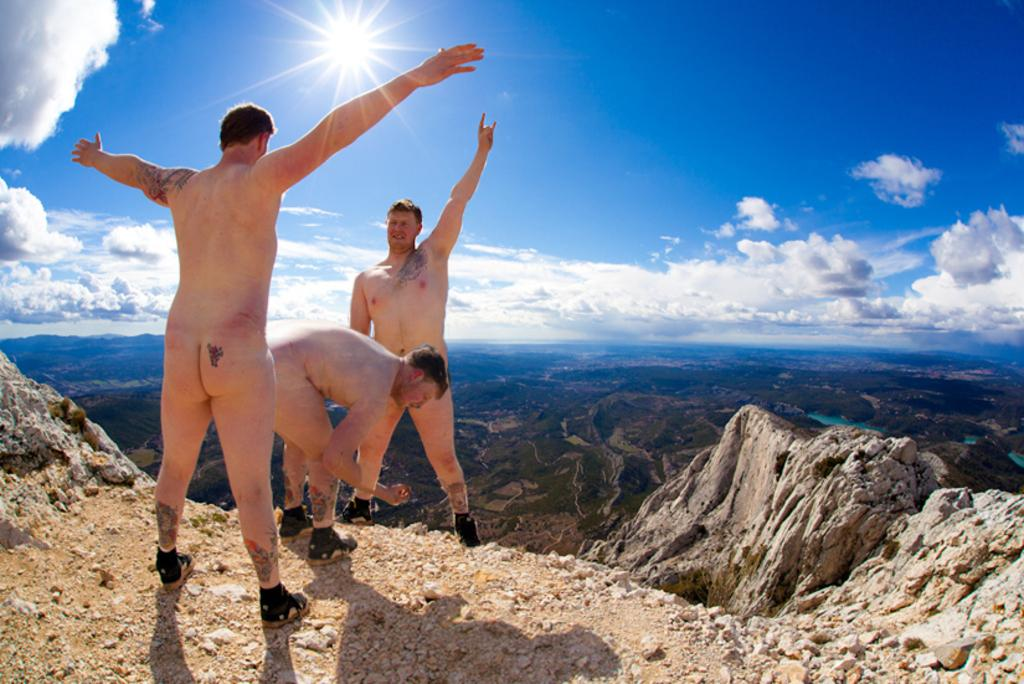How many people are in the image? There are three people in the image. What are the positions of the people in the image? Two of the people are standing. What can be seen in the background of the image? The background of the image includes the sky. What is the condition of the sky in the image? Clouds are visible in the sky. What type of vacation is the writer planning in the image? There is no writer or vacation mentioned in the image; it features three people and a sky with clouds. 